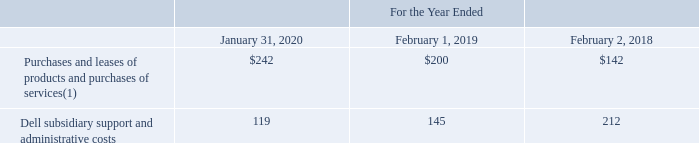Information about VMware’s payments for such arrangements during the periods presented consisted of the following (table in millions):
1) Amount includes indirect taxes that were remitted to Dell during the periods presented.
VMware also purchases Dell products through Dell’s channel partners. Purchases of Dell products through Dell’s channel partners were not significant during the periods presented.
From time to time, VMware and Dell also enter into joint marketing, sales, branding and product development arrangements, for which both parties may incur costs.
During the fourth quarter of fiscal 2020, VMware entered into an arrangement with Dell to transfer approximately 250 professional services employees from Dell to VMware. These employees are experienced in providing professional services delivering VMware technology and this transfer centralizes these resources within the Company in order to serve its customers more efficiently and effectively. The transfer was substantially completed during the fourth quarter of fiscal 2020 and did not have a material impact to the consolidated financial statements. VMware also expects that Dell will resell VMware consulting solutions.
During the third quarter of fiscal 2019, VMware acquired technology and employees related to the Dell EMC Service Assurance Suite, which provides root cause analysis management software for communications service providers, from Dell. The purchase of the Dell EMC Service Assurance Suite was accounted for as a transaction by entities under common control. The amount of the purchase price in excess of the historical cost of the acquired assets was recognized as a reduction to retained earnings on the consolidated balance sheets. Transition services were provided by Dell over a period of 18 months, starting from the date of the acquisition, which were not significant.
During the second quarter of fiscal 2018, VMware acquired Wavefront, Inc. (“Wavefront”). Upon closing of the acquisition, Dell was paid $20 million in cash for its non-controlling ownership interest in Wavefront.
What did Purchases and leases of products and purchases of services include? Indirect taxes that were remitted to dell during the periods presented. Which years does the table provide information for VMware’s payments for such arrangements? 2020, 2019, 2018. What were the Dell subsidiary support and administrative costs in 2020?
Answer scale should be: million. 119. What was the change in Purchases and leases of products and purchases of services between 2018 and 2019?
Answer scale should be: million. 200-142
Answer: 58. How many years did Dell subsidiary support and administrative costs exceed $150 million? 2018
Answer: 1. What was the percentage change in Dell subsidiary support and administrative costs between 2019 and 2020?
Answer scale should be: percent. (119-145)/145
Answer: -17.93. 